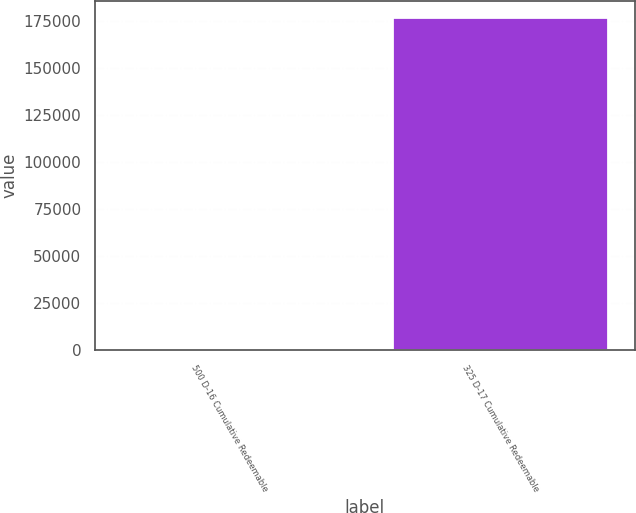<chart> <loc_0><loc_0><loc_500><loc_500><bar_chart><fcel>500 D-16 Cumulative Redeemable<fcel>325 D-17 Cumulative Redeemable<nl><fcel>1<fcel>177100<nl></chart> 